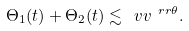Convert formula to latex. <formula><loc_0><loc_0><loc_500><loc_500>\Theta _ { 1 } ( t ) + \Theta _ { 2 } ( t ) \lesssim \ v v ^ { \ r r \theta } .</formula> 